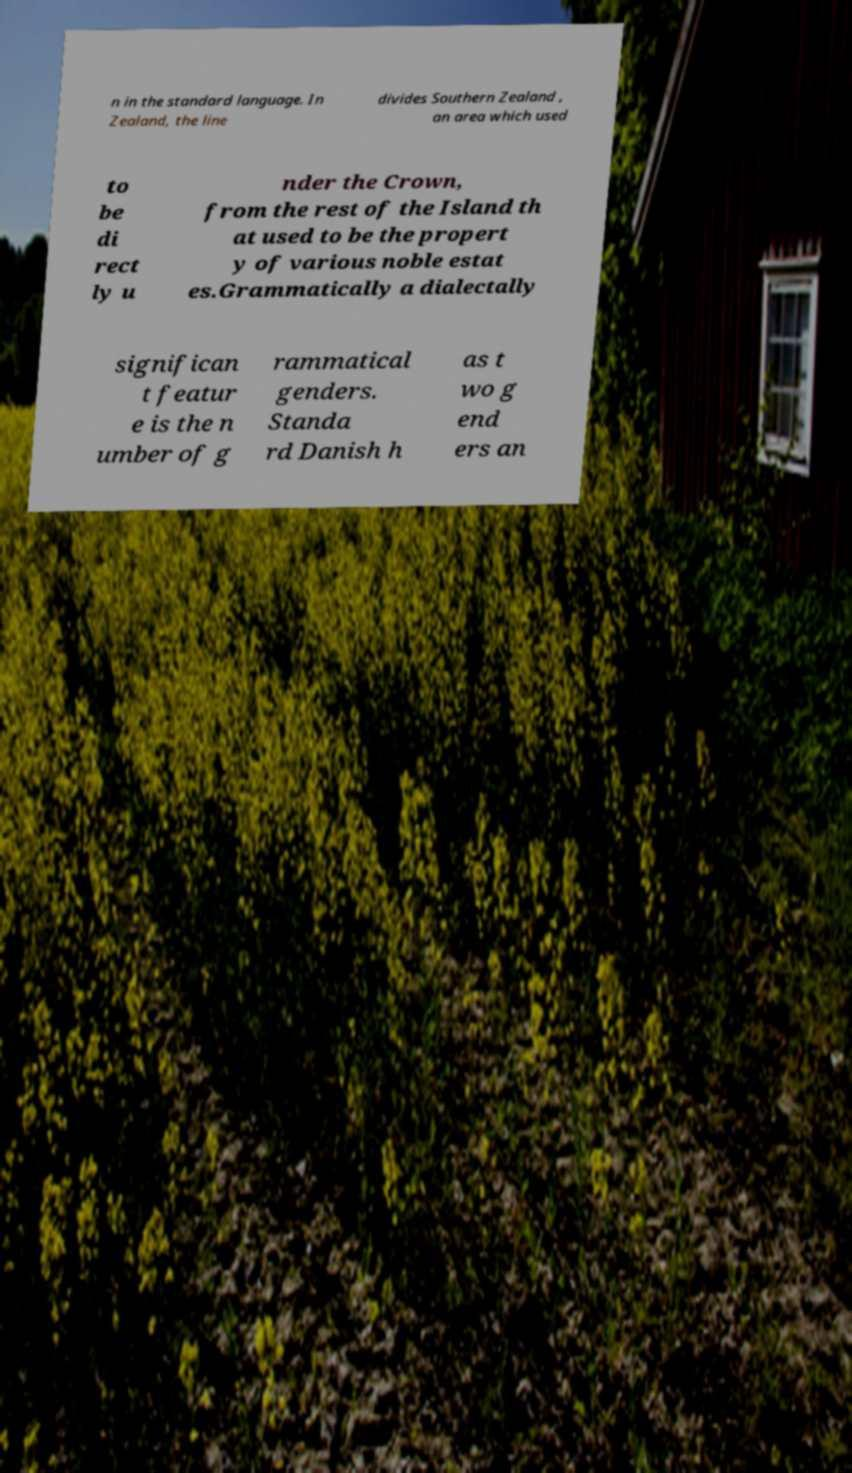Please identify and transcribe the text found in this image. n in the standard language. In Zealand, the line divides Southern Zealand , an area which used to be di rect ly u nder the Crown, from the rest of the Island th at used to be the propert y of various noble estat es.Grammatically a dialectally significan t featur e is the n umber of g rammatical genders. Standa rd Danish h as t wo g end ers an 